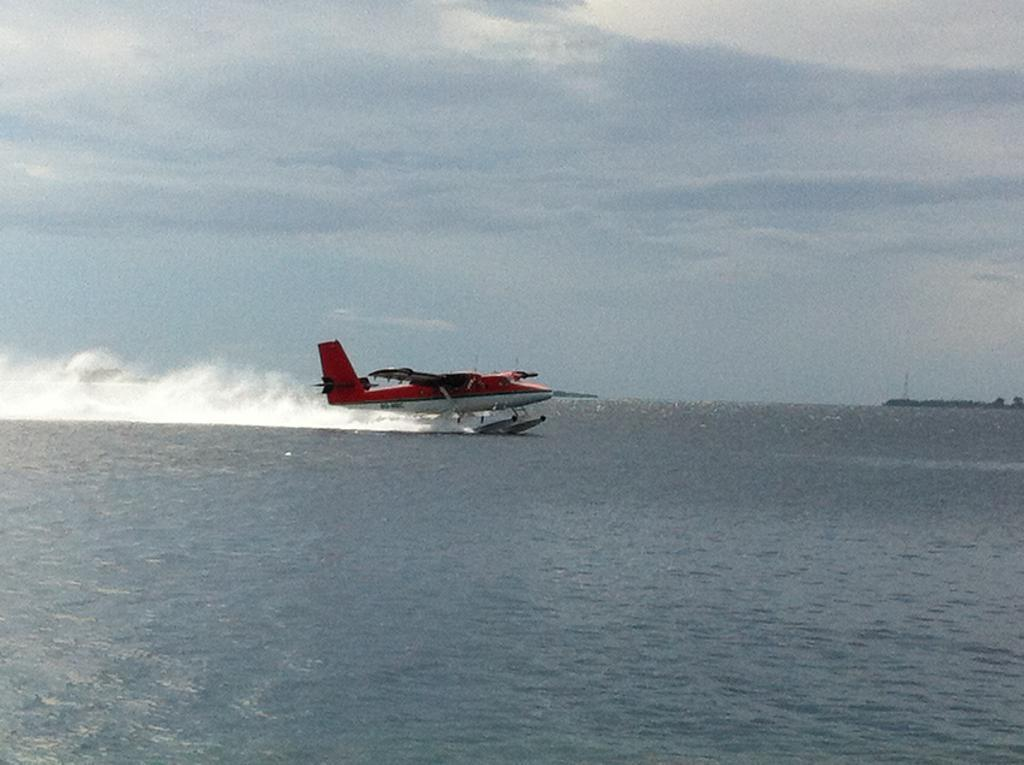What type of aircraft is in the image? There is a seaplane in the image. What is the seaplane doing in the image? The seaplane is moving on the water. What type of water surface is the seaplane moving on? The water is likely the sea. What is visible in the background of the image? The sky is visible in the image. Where is the step located in the image? There is no step present in the image. What type of bed can be seen in the image? There is no bed present in the image. What is the seaplane carrying in the image? The seaplane is not carrying any visible bags or luggage in the image. 